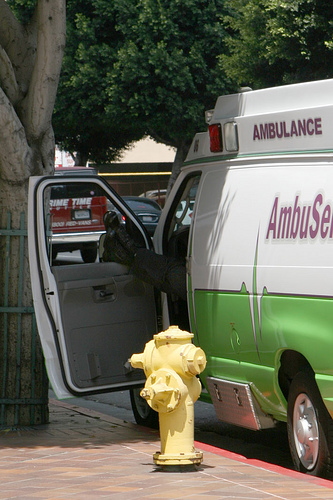<image>What is the name of the car? I don't know the exact name of the car. It could be an ambulance or a van. What is the name of the car? I don't know the name of the car. It seems like it is an ambulance. 